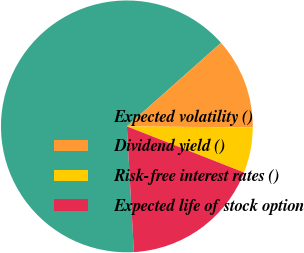Convert chart. <chart><loc_0><loc_0><loc_500><loc_500><pie_chart><fcel>Expected volatility ()<fcel>Dividend yield ()<fcel>Risk-free interest rates ()<fcel>Expected life of stock option<nl><fcel>64.34%<fcel>11.69%<fcel>5.83%<fcel>18.14%<nl></chart> 